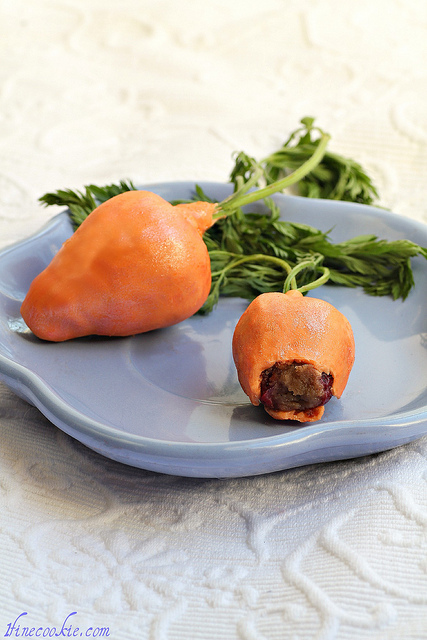<image>What food is shown? It is unknown what food is shown. It could be a turnip, carrot, beet or kumquat. What food is shown? I don't know what food is shown. It can be turnip, vegetable, carrot, beet or kumquat. 